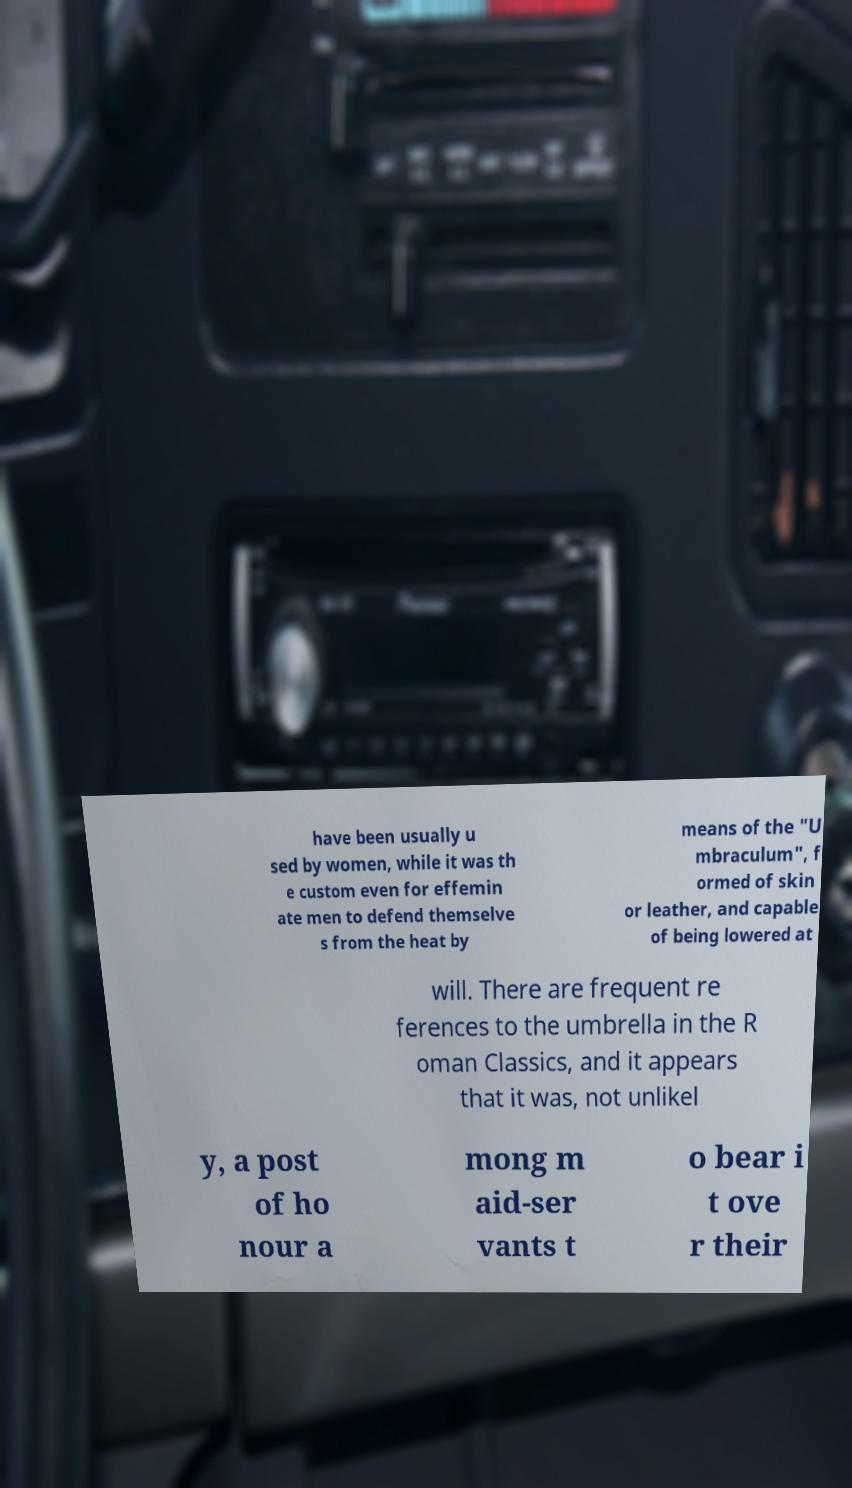What messages or text are displayed in this image? I need them in a readable, typed format. have been usually u sed by women, while it was th e custom even for effemin ate men to defend themselve s from the heat by means of the "U mbraculum", f ormed of skin or leather, and capable of being lowered at will. There are frequent re ferences to the umbrella in the R oman Classics, and it appears that it was, not unlikel y, a post of ho nour a mong m aid-ser vants t o bear i t ove r their 